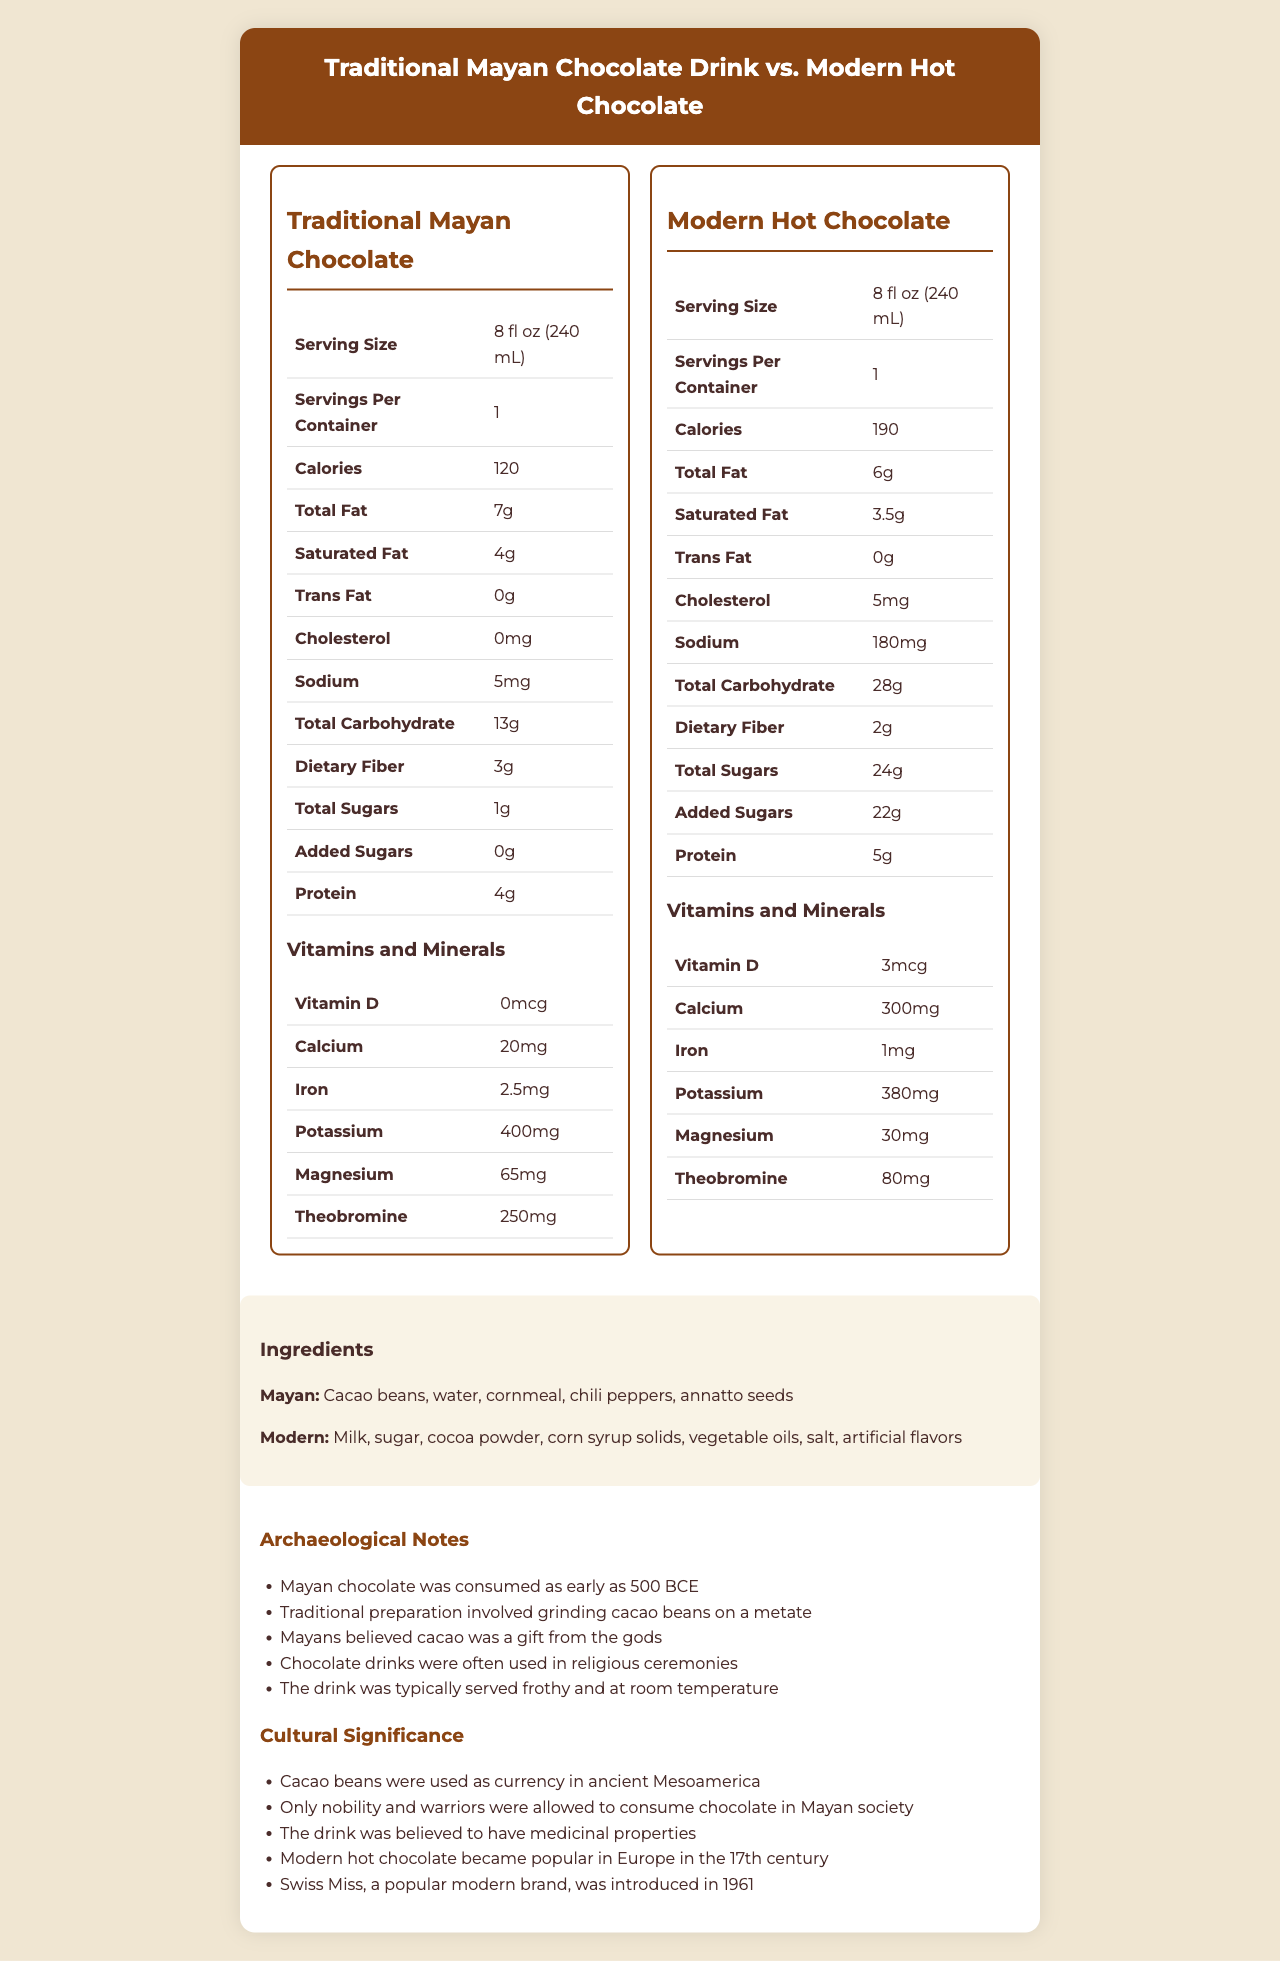what is the serving size for both drinks? The serving size is presented as "8 fl oz (240 mL)" in the "Serving Size" row for both the traditional Mayan chocolate drink and modern hot chocolate.
Answer: 8 fl oz (240 mL) how many calories are in a serving of traditional Mayan chocolate drink? The "Calories" row indicates "120" for the traditional Mayan chocolate drink.
Answer: 120 how much sodium does modern hot chocolate contain? In the "Sodium" row, the value for modern hot chocolate is listed as "180mg".
Answer: 180mg which drink contains more total sugars? A. Traditional Mayan chocolate drink B. Modern hot chocolate The "Total Sugars" row shows "1g" for the traditional Mayan chocolate drink and "24g" for modern hot chocolate.
Answer: B what is the protein content in modern hot chocolate? The "Protein" row lists "5g" as the protein content for modern hot chocolate.
Answer: 5g compare the sodium content in both drinks; which one is higher? The traditional Mayan chocolate drink contains 5mg of sodium while modern hot chocolate contains 180mg.
Answer: Modern hot chocolate does the traditional Mayan chocolate drink contain any cholesterol? The "Cholesterol" row indicates "0mg" for the traditional Mayan chocolate drink.
Answer: No which drink has a higher amount of dietary fiber? A. Traditional Mayan chocolate drink B. Modern hot chocolate The "Dietary Fiber" row indicates "3g" for the traditional Mayan chocolate drink and "2g" for modern hot chocolate.
Answer: A is the total fat content higher in traditional Mayan chocolate drink compared to modern hot chocolate? The traditional Mayan chocolate drink has "7g" total fat, whereas modern hot chocolate has "6g".
Answer: Yes describe the different ingredients found in the traditional Mayan chocolate drink and modern hot chocolate. The document displays the ingredients under the "Ingredients" section for both drinks.
Answer: Traditional Mayan chocolate drink contains cacao beans, water, cornmeal, chili peppers, and annatto seeds. Modern hot chocolate contains milk, sugar, cocoa powder, corn syrup solids, vegetable oils, salt, and artificial flavors. which drink has a higher amount of theobromine? In the vitamins and minerals section, theobromine level is "250mg" for the traditional Mayan chocolate drink and "80mg" for modern hot chocolate.
Answer: Traditional Mayan chocolate drink what is the significance of cacao beans in ancient Mesoamerica? One of the points listed in the "Cultural Significance" section mentions that cacao beans were used as currency in ancient Mesoamerica.
Answer: Cacao beans were used as currency in ancient Mesoamerica. what is one aspect of how the Mayans traditionally prepared their chocolate drink? In the "Archaeological Notes" section, one note specifies that traditional Mayan preparation involved grinding cacao beans on a metate.
Answer: They ground cacao beans on a metate. was modern hot chocolate typically served frothy and at room temperature like Mayan chocolate? The document only specifies that the traditional Mayan chocolate drink was typically served frothy and at room temperature and does not provide information about how modern hot chocolate is served.
Answer: Cannot be determined summarize the main differences in nutritional content between the traditional Mayan chocolate drink and modern hot chocolate. The document provides a detailed comparison of nutritional content, ingredients, and cultural significance for both drinks, highlighting the natural composition and lower sugar content of the traditional Mayan chocolate drink and the higher calories and processed ingredients of modern hot chocolate. The notes dive into historical preparation methods and usage in ceremonies, contrasting with the modern iteration's popularity and brand introduction.
Answer: The traditional Mayan chocolate drink is lower in calories, total sugars, and sodium than modern hot chocolate. While it has more dietary fiber and theobromine, the modern hot chocolate has slightly more protein, added sugars, and vitamins such as Vitamin D, Calcium, and Cholesterol. The ingredients reflect a significant difference, with traditional Mayan ingredients being more natural and less processed compared to the modern version. Cultural and preparation methods also underscore the historical and ritualistic significance of the Mayan chocolate drink. 